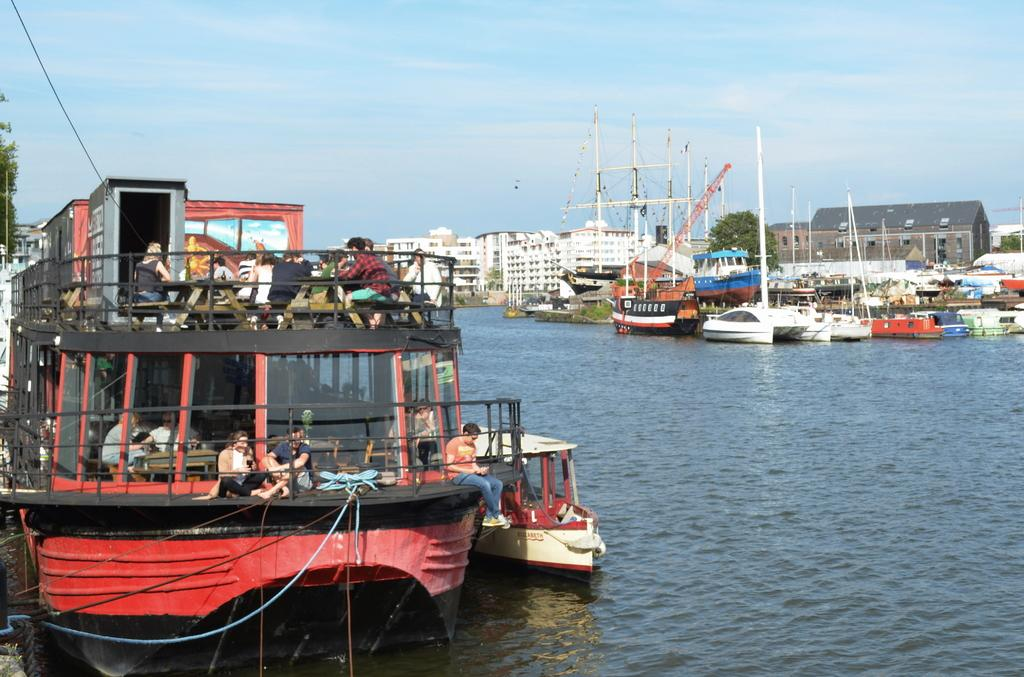What are the people in the image doing? The people in the image are on a boat. What can be seen in the background of the image? In the background of the image, there are boats, water, buildings, the sky, trees, and other objects. How many boats are visible in the image? There is one boat with people on it, and there are additional boats visible in the background. What type of prose is being recited by the trees in the background of the image? There are no trees reciting prose in the image; the trees are part of the natural landscape in the background. 